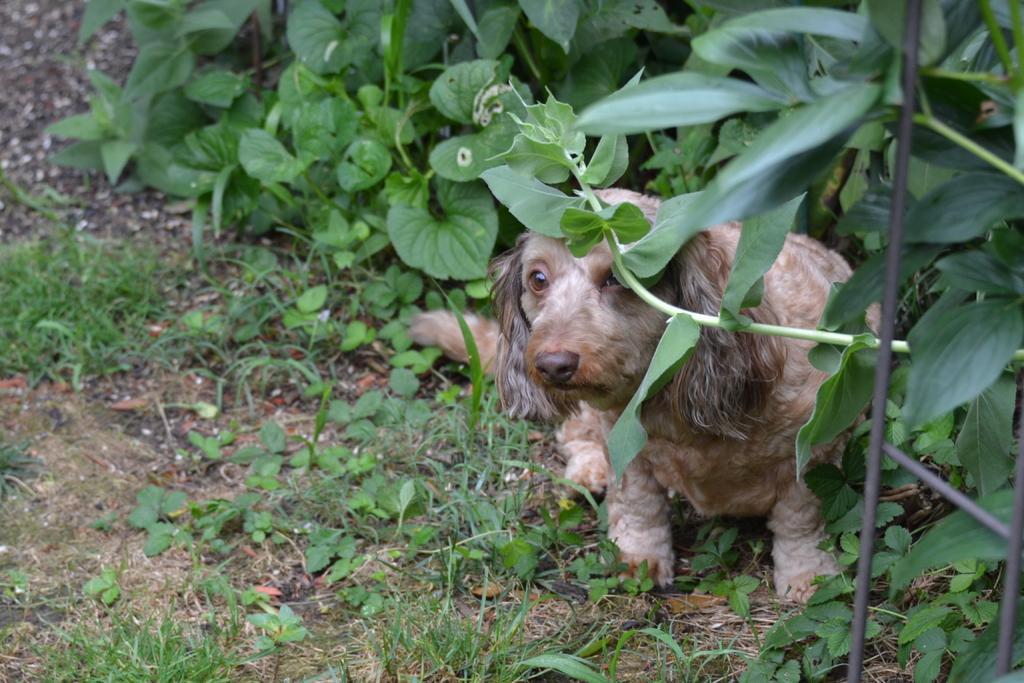Could you give a brief overview of what you see in this image? This is a dog sitting. These are the plants. I can see the grass. 